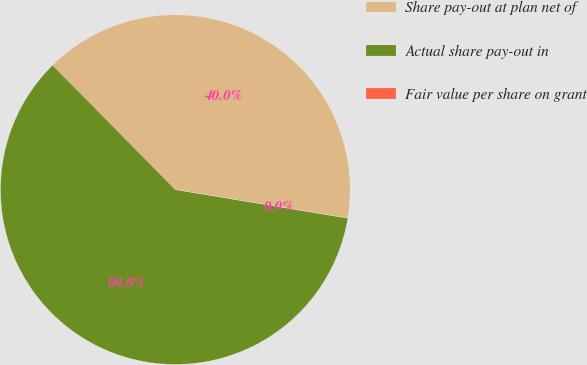<chart> <loc_0><loc_0><loc_500><loc_500><pie_chart><fcel>Share pay-out at plan net of<fcel>Actual share pay-out in<fcel>Fair value per share on grant<nl><fcel>40.0%<fcel>60.0%<fcel>0.01%<nl></chart> 